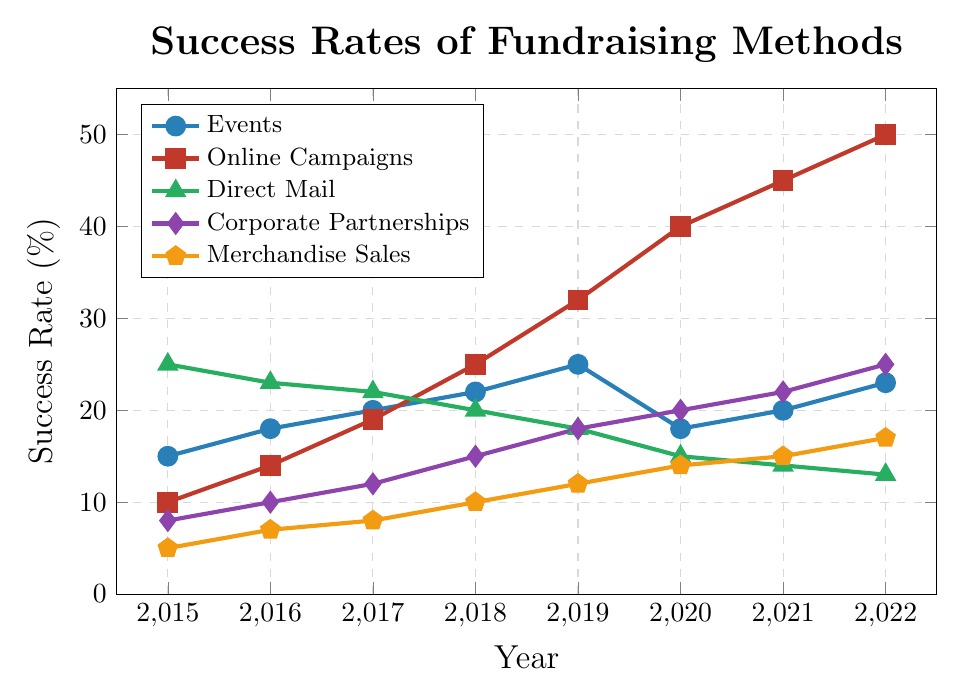What year did online campaigns surpass the 30% success rate? Looking at the plot for online campaigns (marked by squares and in red), the success rate surpasses 30% between 2018 and 2019. The data point for 2019 shows a value of 32%.
Answer: 2019 Between 2017 and 2020, which fundraising method saw a consistent decline in success rate? Observing the trends, direct mail (marked by triangles and in green) shows a consistent decline from 2017 (22%) to 2020 (15%).
Answer: Direct Mail Which year had the highest overall success rate for online campaigns? Referencing the red squares line, the highest value is 50%, which occurs in 2022.
Answer: 2022 By how much did the success rate for merchandise sales increase from 2015 to 2022? The initial value in 2015 is 5% and the value in 2022 is 17%. Subtracting 5 from 17 gives us 12%.
Answer: 12% Which two fundraising methods had similar success rates in 2015? In 2015, the values for merchandise sales and corporate partnerships are 5% and 8% respectively. These are the closest values in that year.
Answer: Merchandise Sales and Corporate Partnerships What is the average success rate for events over the given period? Summing the success rates for events from 2015 to 2022: 15 + 18 + 20 + 22 + 25 + 18 + 20 + 23 = 161. Dividing this by 8 (the number of years) gives us 161/8 = 20.125%.
Answer: 20.125% Which method had the largest decrease in success rate between any two consecutive years? The success rate for direct mail drops from 25% in 2015 to 23% in 2016, a decrease of 2. The largest decrease occurs for Events from 2019 (25%) to 2020 (18%), a 7% decrease.
Answer: Events For how many years did corporate partnerships have a higher success rate than direct mail? Comparing the success rates year by year, corporate partnerships exceeded direct mail in the years 2020, 2021, and 2022, totaling 3 years.
Answer: 3 How did the success rate for online campaigns change between 2018 and 2021? The success rate for online campaigns in 2018 is 25% and increases to 45% in 2021. The difference is 45 - 25 = 20%.
Answer: Increased by 20% 